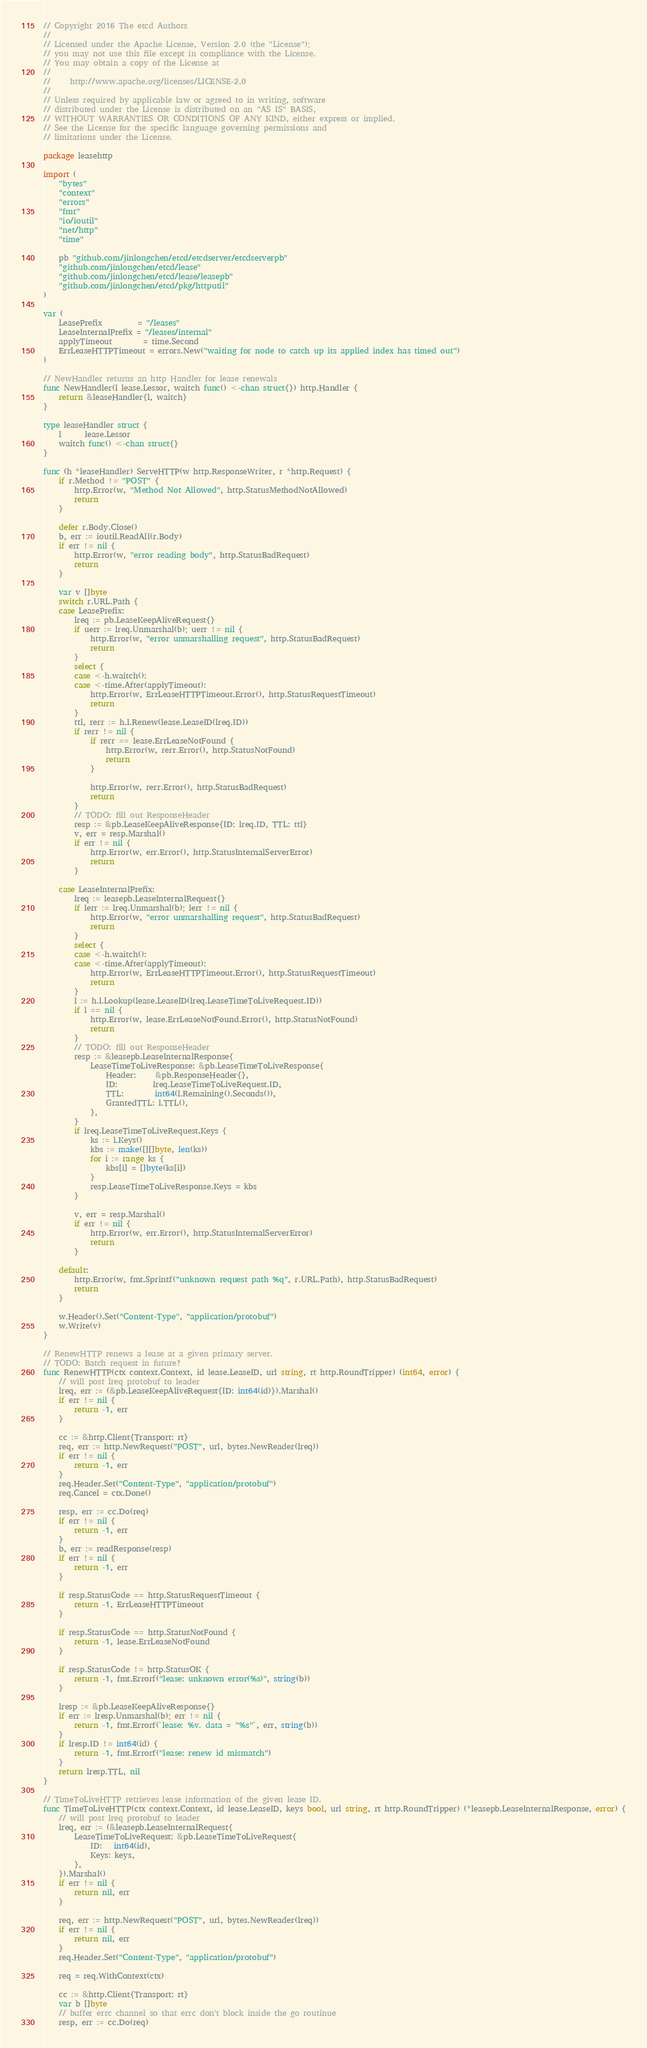<code> <loc_0><loc_0><loc_500><loc_500><_Go_>// Copyright 2016 The etcd Authors
//
// Licensed under the Apache License, Version 2.0 (the "License");
// you may not use this file except in compliance with the License.
// You may obtain a copy of the License at
//
//     http://www.apache.org/licenses/LICENSE-2.0
//
// Unless required by applicable law or agreed to in writing, software
// distributed under the License is distributed on an "AS IS" BASIS,
// WITHOUT WARRANTIES OR CONDITIONS OF ANY KIND, either express or implied.
// See the License for the specific language governing permissions and
// limitations under the License.

package leasehttp

import (
	"bytes"
	"context"
	"errors"
	"fmt"
	"io/ioutil"
	"net/http"
	"time"

	pb "github.com/jinlongchen/etcd/etcdserver/etcdserverpb"
	"github.com/jinlongchen/etcd/lease"
	"github.com/jinlongchen/etcd/lease/leasepb"
	"github.com/jinlongchen/etcd/pkg/httputil"
)

var (
	LeasePrefix         = "/leases"
	LeaseInternalPrefix = "/leases/internal"
	applyTimeout        = time.Second
	ErrLeaseHTTPTimeout = errors.New("waiting for node to catch up its applied index has timed out")
)

// NewHandler returns an http Handler for lease renewals
func NewHandler(l lease.Lessor, waitch func() <-chan struct{}) http.Handler {
	return &leaseHandler{l, waitch}
}

type leaseHandler struct {
	l      lease.Lessor
	waitch func() <-chan struct{}
}

func (h *leaseHandler) ServeHTTP(w http.ResponseWriter, r *http.Request) {
	if r.Method != "POST" {
		http.Error(w, "Method Not Allowed", http.StatusMethodNotAllowed)
		return
	}

	defer r.Body.Close()
	b, err := ioutil.ReadAll(r.Body)
	if err != nil {
		http.Error(w, "error reading body", http.StatusBadRequest)
		return
	}

	var v []byte
	switch r.URL.Path {
	case LeasePrefix:
		lreq := pb.LeaseKeepAliveRequest{}
		if uerr := lreq.Unmarshal(b); uerr != nil {
			http.Error(w, "error unmarshalling request", http.StatusBadRequest)
			return
		}
		select {
		case <-h.waitch():
		case <-time.After(applyTimeout):
			http.Error(w, ErrLeaseHTTPTimeout.Error(), http.StatusRequestTimeout)
			return
		}
		ttl, rerr := h.l.Renew(lease.LeaseID(lreq.ID))
		if rerr != nil {
			if rerr == lease.ErrLeaseNotFound {
				http.Error(w, rerr.Error(), http.StatusNotFound)
				return
			}

			http.Error(w, rerr.Error(), http.StatusBadRequest)
			return
		}
		// TODO: fill out ResponseHeader
		resp := &pb.LeaseKeepAliveResponse{ID: lreq.ID, TTL: ttl}
		v, err = resp.Marshal()
		if err != nil {
			http.Error(w, err.Error(), http.StatusInternalServerError)
			return
		}

	case LeaseInternalPrefix:
		lreq := leasepb.LeaseInternalRequest{}
		if lerr := lreq.Unmarshal(b); lerr != nil {
			http.Error(w, "error unmarshalling request", http.StatusBadRequest)
			return
		}
		select {
		case <-h.waitch():
		case <-time.After(applyTimeout):
			http.Error(w, ErrLeaseHTTPTimeout.Error(), http.StatusRequestTimeout)
			return
		}
		l := h.l.Lookup(lease.LeaseID(lreq.LeaseTimeToLiveRequest.ID))
		if l == nil {
			http.Error(w, lease.ErrLeaseNotFound.Error(), http.StatusNotFound)
			return
		}
		// TODO: fill out ResponseHeader
		resp := &leasepb.LeaseInternalResponse{
			LeaseTimeToLiveResponse: &pb.LeaseTimeToLiveResponse{
				Header:     &pb.ResponseHeader{},
				ID:         lreq.LeaseTimeToLiveRequest.ID,
				TTL:        int64(l.Remaining().Seconds()),
				GrantedTTL: l.TTL(),
			},
		}
		if lreq.LeaseTimeToLiveRequest.Keys {
			ks := l.Keys()
			kbs := make([][]byte, len(ks))
			for i := range ks {
				kbs[i] = []byte(ks[i])
			}
			resp.LeaseTimeToLiveResponse.Keys = kbs
		}

		v, err = resp.Marshal()
		if err != nil {
			http.Error(w, err.Error(), http.StatusInternalServerError)
			return
		}

	default:
		http.Error(w, fmt.Sprintf("unknown request path %q", r.URL.Path), http.StatusBadRequest)
		return
	}

	w.Header().Set("Content-Type", "application/protobuf")
	w.Write(v)
}

// RenewHTTP renews a lease at a given primary server.
// TODO: Batch request in future?
func RenewHTTP(ctx context.Context, id lease.LeaseID, url string, rt http.RoundTripper) (int64, error) {
	// will post lreq protobuf to leader
	lreq, err := (&pb.LeaseKeepAliveRequest{ID: int64(id)}).Marshal()
	if err != nil {
		return -1, err
	}

	cc := &http.Client{Transport: rt}
	req, err := http.NewRequest("POST", url, bytes.NewReader(lreq))
	if err != nil {
		return -1, err
	}
	req.Header.Set("Content-Type", "application/protobuf")
	req.Cancel = ctx.Done()

	resp, err := cc.Do(req)
	if err != nil {
		return -1, err
	}
	b, err := readResponse(resp)
	if err != nil {
		return -1, err
	}

	if resp.StatusCode == http.StatusRequestTimeout {
		return -1, ErrLeaseHTTPTimeout
	}

	if resp.StatusCode == http.StatusNotFound {
		return -1, lease.ErrLeaseNotFound
	}

	if resp.StatusCode != http.StatusOK {
		return -1, fmt.Errorf("lease: unknown error(%s)", string(b))
	}

	lresp := &pb.LeaseKeepAliveResponse{}
	if err := lresp.Unmarshal(b); err != nil {
		return -1, fmt.Errorf(`lease: %v. data = "%s"`, err, string(b))
	}
	if lresp.ID != int64(id) {
		return -1, fmt.Errorf("lease: renew id mismatch")
	}
	return lresp.TTL, nil
}

// TimeToLiveHTTP retrieves lease information of the given lease ID.
func TimeToLiveHTTP(ctx context.Context, id lease.LeaseID, keys bool, url string, rt http.RoundTripper) (*leasepb.LeaseInternalResponse, error) {
	// will post lreq protobuf to leader
	lreq, err := (&leasepb.LeaseInternalRequest{
		LeaseTimeToLiveRequest: &pb.LeaseTimeToLiveRequest{
			ID:   int64(id),
			Keys: keys,
		},
	}).Marshal()
	if err != nil {
		return nil, err
	}

	req, err := http.NewRequest("POST", url, bytes.NewReader(lreq))
	if err != nil {
		return nil, err
	}
	req.Header.Set("Content-Type", "application/protobuf")

	req = req.WithContext(ctx)

	cc := &http.Client{Transport: rt}
	var b []byte
	// buffer errc channel so that errc don't block inside the go routinue
	resp, err := cc.Do(req)</code> 